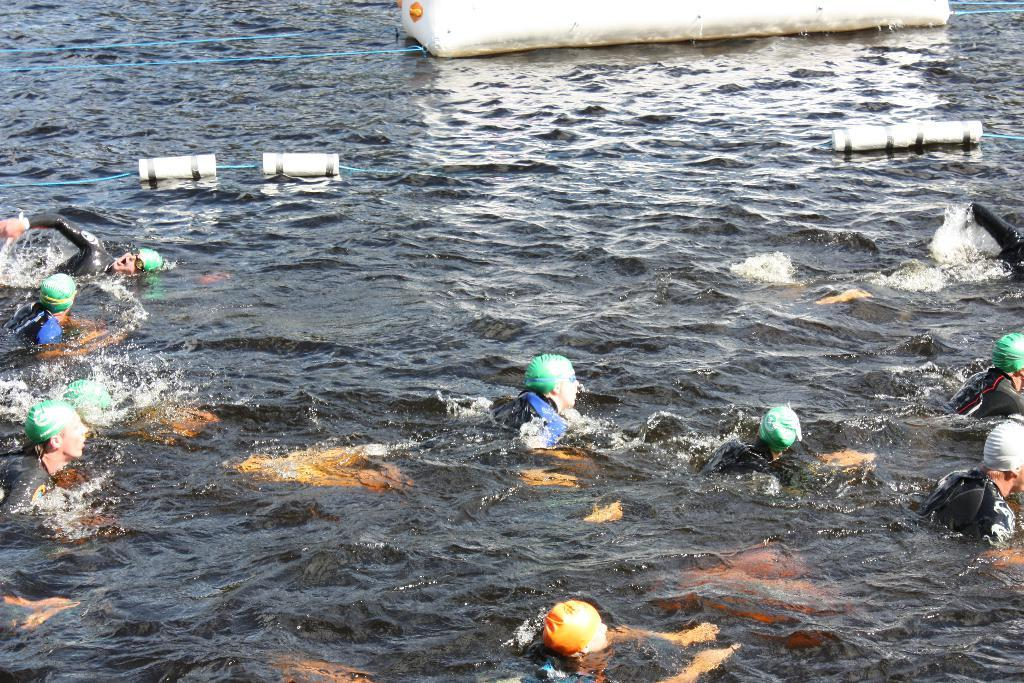Who is present in the image? There are people in the image. What are the people wearing? The people are wearing swimsuits. What activity are the people engaged in? The people are swimming in the water. What can be seen floating on the water? There are white-colored objects floating on the water. What language is being spoken by the cat in the image? There is no cat present in the image, so it is not possible to determine what language it might be speaking. 